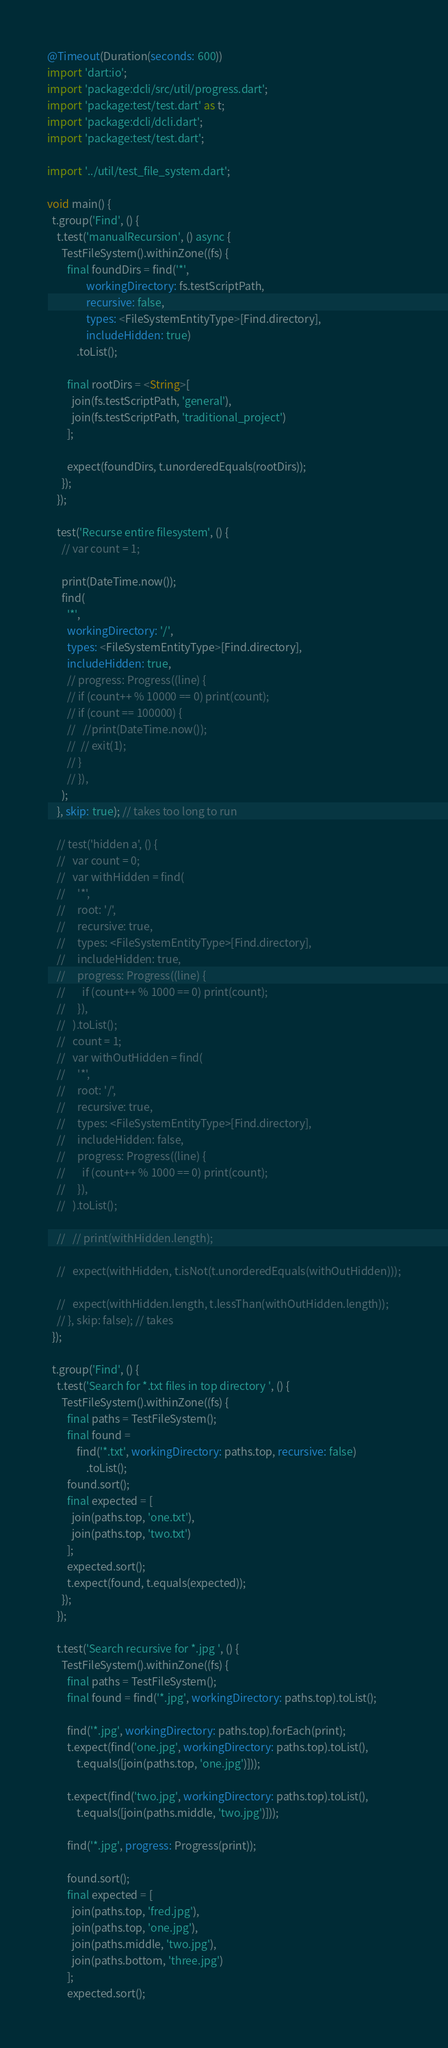<code> <loc_0><loc_0><loc_500><loc_500><_Dart_>@Timeout(Duration(seconds: 600))
import 'dart:io';
import 'package:dcli/src/util/progress.dart';
import 'package:test/test.dart' as t;
import 'package:dcli/dcli.dart';
import 'package:test/test.dart';

import '../util/test_file_system.dart';

void main() {
  t.group('Find', () {
    t.test('manualRecursion', () async {
      TestFileSystem().withinZone((fs) {
        final foundDirs = find('*',
                workingDirectory: fs.testScriptPath,
                recursive: false,
                types: <FileSystemEntityType>[Find.directory],
                includeHidden: true)
            .toList();

        final rootDirs = <String>[
          join(fs.testScriptPath, 'general'),
          join(fs.testScriptPath, 'traditional_project')
        ];

        expect(foundDirs, t.unorderedEquals(rootDirs));
      });
    });

    test('Recurse entire filesystem', () {
      // var count = 1;

      print(DateTime.now());
      find(
        '*',
        workingDirectory: '/',
        types: <FileSystemEntityType>[Find.directory],
        includeHidden: true,
        // progress: Progress((line) {
        // if (count++ % 10000 == 0) print(count);
        // if (count == 100000) {
        //   //print(DateTime.now());
        //  // exit(1);
        // }
        // }),
      );
    }, skip: true); // takes too long to run

    // test('hidden a', () {
    //   var count = 0;
    //   var withHidden = find(
    //     '*',
    //     root: '/',
    //     recursive: true,
    //     types: <FileSystemEntityType>[Find.directory],
    //     includeHidden: true,
    //     progress: Progress((line) {
    //       if (count++ % 1000 == 0) print(count);
    //     }),
    //   ).toList();
    //   count = 1;
    //   var withOutHidden = find(
    //     '*',
    //     root: '/',
    //     recursive: true,
    //     types: <FileSystemEntityType>[Find.directory],
    //     includeHidden: false,
    //     progress: Progress((line) {
    //       if (count++ % 1000 == 0) print(count);
    //     }),
    //   ).toList();

    //   // print(withHidden.length);

    //   expect(withHidden, t.isNot(t.unorderedEquals(withOutHidden)));

    //   expect(withHidden.length, t.lessThan(withOutHidden.length));
    // }, skip: false); // takes
  });

  t.group('Find', () {
    t.test('Search for *.txt files in top directory ', () {
      TestFileSystem().withinZone((fs) {
        final paths = TestFileSystem();
        final found =
            find('*.txt', workingDirectory: paths.top, recursive: false)
                .toList();
        found.sort();
        final expected = [
          join(paths.top, 'one.txt'),
          join(paths.top, 'two.txt')
        ];
        expected.sort();
        t.expect(found, t.equals(expected));
      });
    });

    t.test('Search recursive for *.jpg ', () {
      TestFileSystem().withinZone((fs) {
        final paths = TestFileSystem();
        final found = find('*.jpg', workingDirectory: paths.top).toList();

        find('*.jpg', workingDirectory: paths.top).forEach(print);
        t.expect(find('one.jpg', workingDirectory: paths.top).toList(),
            t.equals([join(paths.top, 'one.jpg')]));

        t.expect(find('two.jpg', workingDirectory: paths.top).toList(),
            t.equals([join(paths.middle, 'two.jpg')]));

        find('*.jpg', progress: Progress(print));

        found.sort();
        final expected = [
          join(paths.top, 'fred.jpg'),
          join(paths.top, 'one.jpg'),
          join(paths.middle, 'two.jpg'),
          join(paths.bottom, 'three.jpg')
        ];
        expected.sort();</code> 